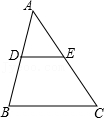In triangle ABC, D and E are the midpoints of the sides AB and AC respectively. If the perimeter of triangle ADE is 30 units, then what is the perimeter of triangle ABC? Since D and E are positioned at the midpoints of sides AB and AC in triangle ABC, each segment AD, DB, AE, and EC is half the length of AB and AC respectively. Consequently, segment DE is also half the length of side BC. This forms a smaller triangle ADE with each side half the length of the corresponding sides in ABC. Therefore, the perimeter of triangle ABC is double that of ADE, which comes to 60 units. Answer: B (60.0 units). This utilizes midsegment theorem crucial in geometry, reflecting the symmetry and proportion inherent in the triangle. 